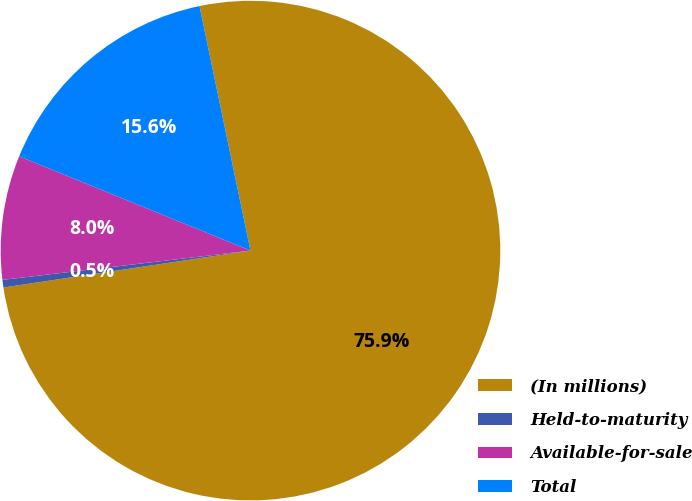<chart> <loc_0><loc_0><loc_500><loc_500><pie_chart><fcel>(In millions)<fcel>Held-to-maturity<fcel>Available-for-sale<fcel>Total<nl><fcel>75.91%<fcel>0.49%<fcel>8.03%<fcel>15.57%<nl></chart> 